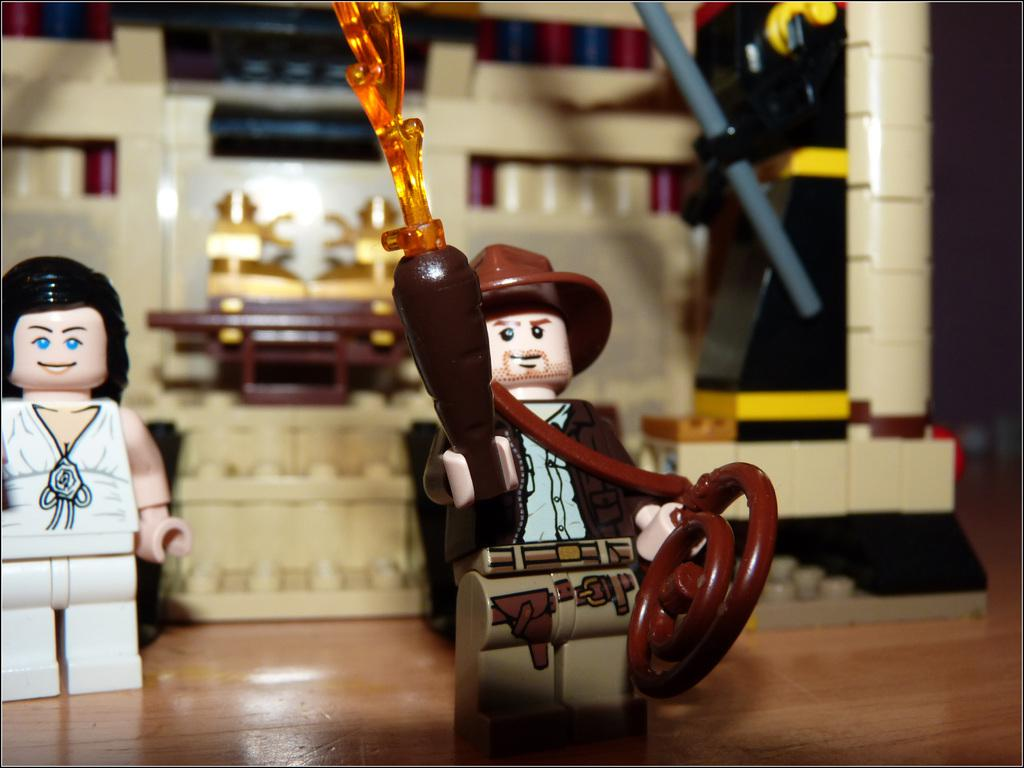What can be seen on the platform in the image? There are toys on a platform in the image. Can you describe the objects visible in the background of the image? Unfortunately, the provided facts do not give any information about the objects visible in the background. How many frogs are present in the image? There are no frogs present in the image. What type of education is being provided in the image? There is no indication of any educational activity in the image. 